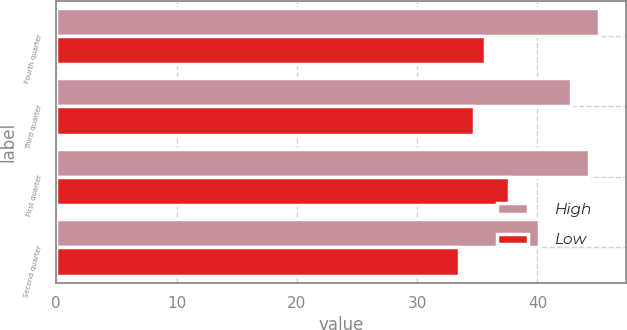Convert chart to OTSL. <chart><loc_0><loc_0><loc_500><loc_500><stacked_bar_chart><ecel><fcel>Fourth quarter<fcel>Third quarter<fcel>First quarter<fcel>Second quarter<nl><fcel>High<fcel>45.14<fcel>42.77<fcel>44.33<fcel>40.13<nl><fcel>Low<fcel>35.65<fcel>34.75<fcel>37.62<fcel>33.48<nl></chart> 